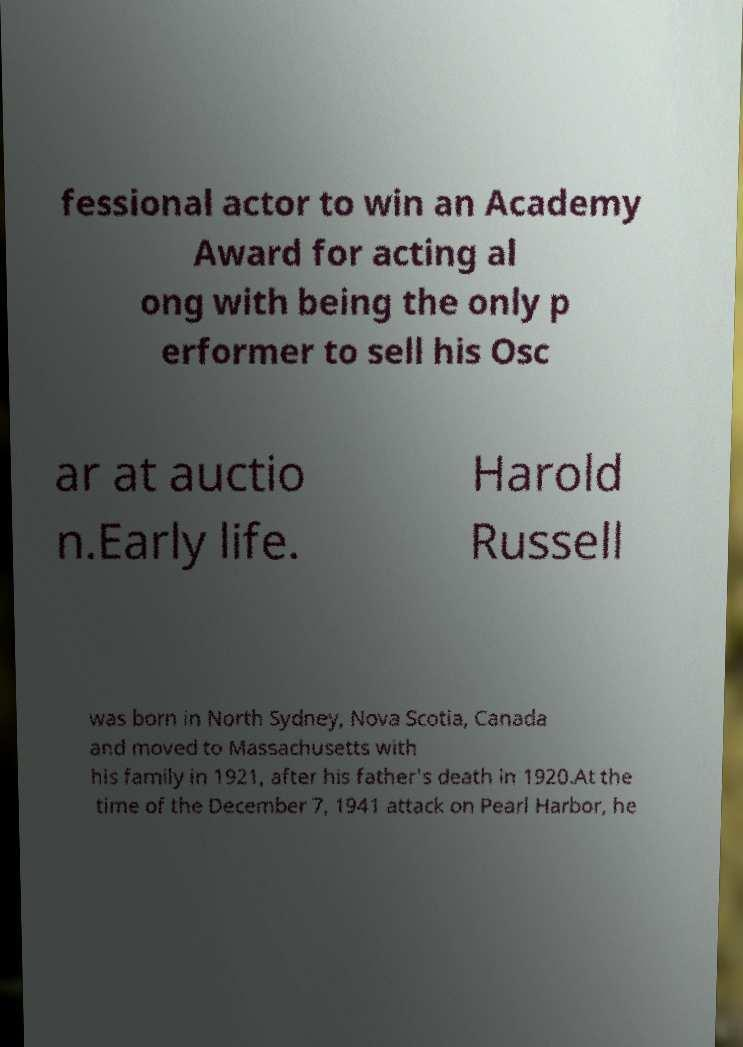Please identify and transcribe the text found in this image. fessional actor to win an Academy Award for acting al ong with being the only p erformer to sell his Osc ar at auctio n.Early life. Harold Russell was born in North Sydney, Nova Scotia, Canada and moved to Massachusetts with his family in 1921, after his father's death in 1920.At the time of the December 7, 1941 attack on Pearl Harbor, he 